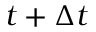Convert formula to latex. <formula><loc_0><loc_0><loc_500><loc_500>t + \Delta t</formula> 